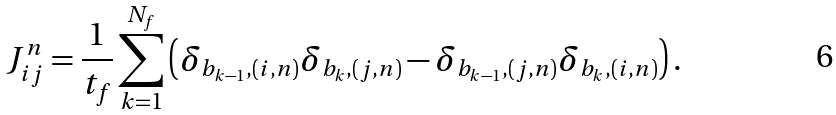Convert formula to latex. <formula><loc_0><loc_0><loc_500><loc_500>J _ { i j } ^ { n } = \frac { 1 } { t _ { f } } \sum _ { k = 1 } ^ { N _ { f } } \left ( \delta _ { b _ { k - 1 } , ( i , n ) } \delta _ { b _ { k } , ( j , n ) } - \delta _ { b _ { k - 1 } , ( j , n ) } \delta _ { b _ { k } , ( i , n ) } \right ) .</formula> 